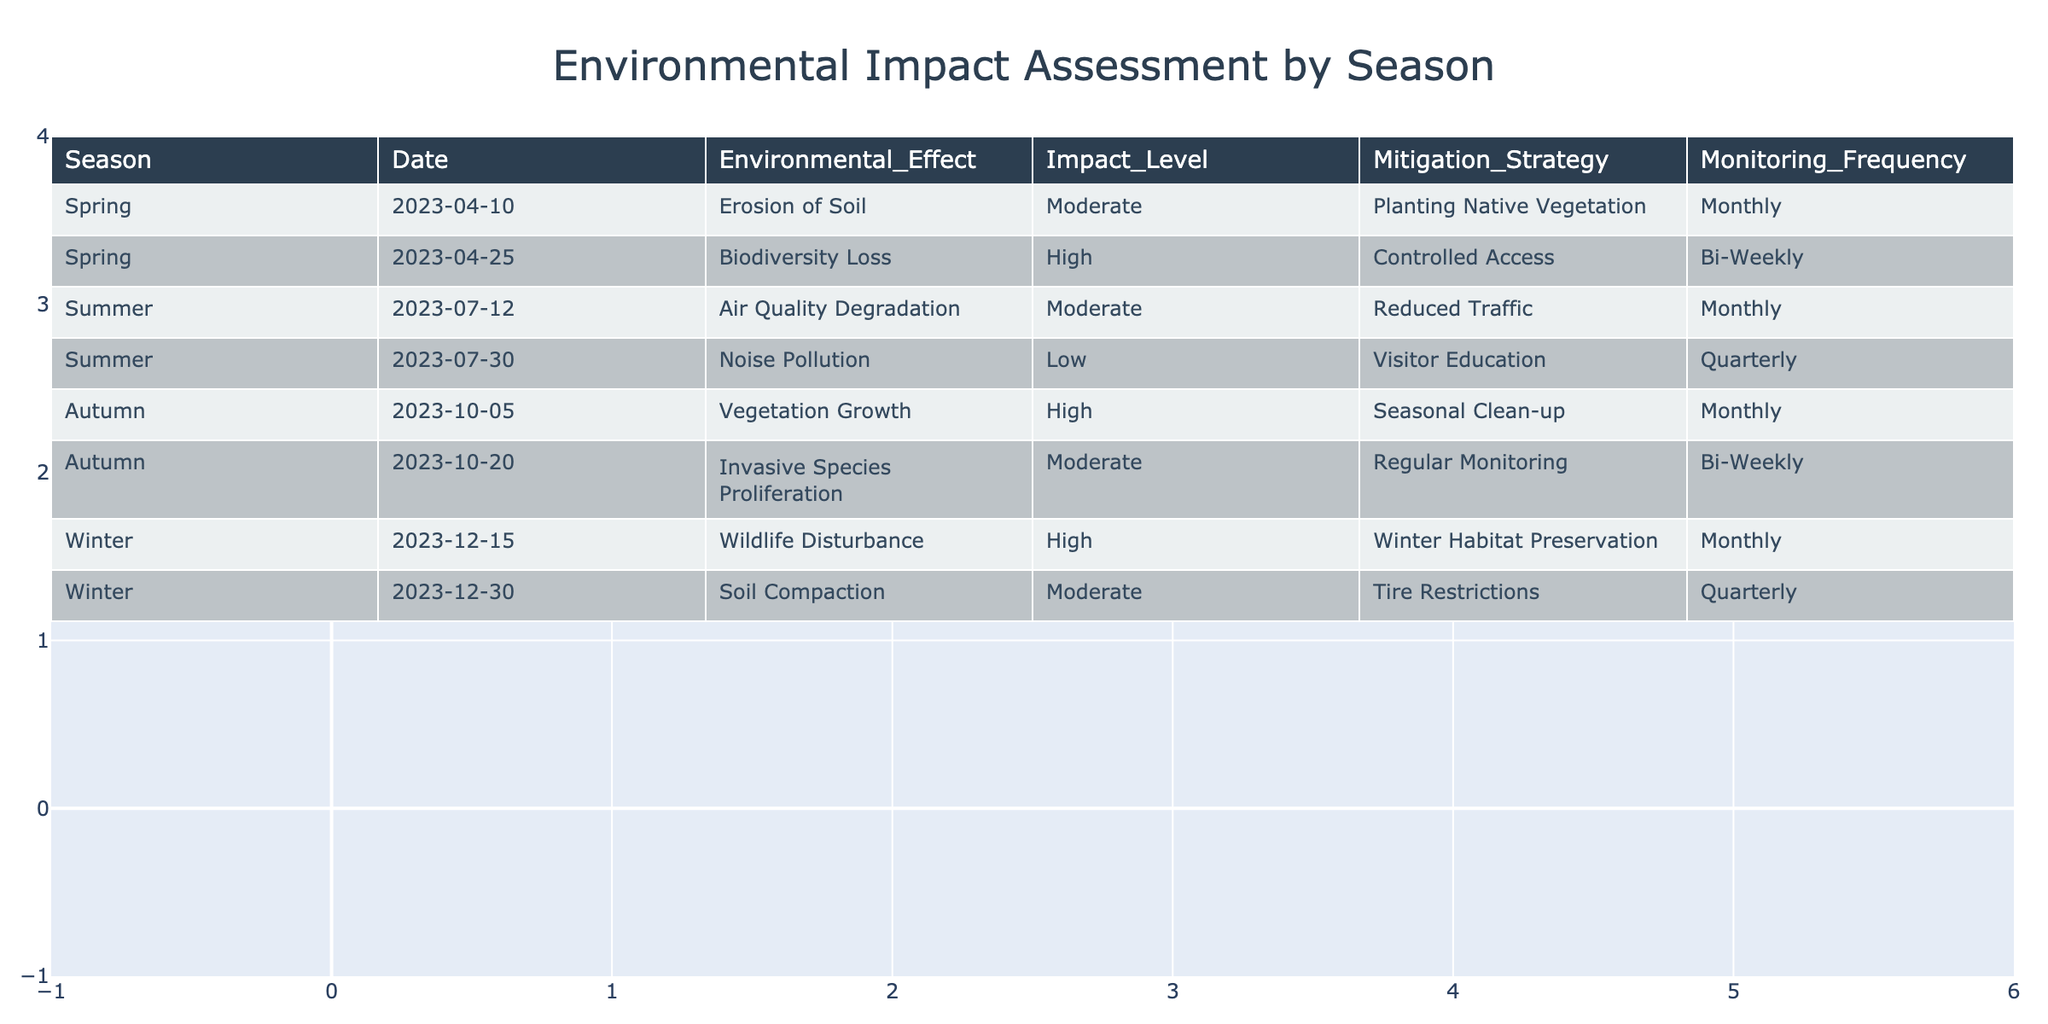What is the environmental effect reported in summer? In the summer season, the table shows two environmental effects: Air Quality Degradation and Noise Pollution. The first one listed is Air Quality Degradation.
Answer: Air Quality Degradation Which season had the highest impact level reported? The table indicates the impact levels for each environmental effect. The highest impact level reported is 'High', which appears in Spring (for Biodiversity Loss), Autumn (for Vegetation Growth), and Winter (for Wildlife Disturbance).
Answer: Spring, Autumn, Winter How many different mitigation strategies are employed across all seasons? A review of the table shows six distinct mitigation strategies: Planting Native Vegetation, Controlled Access, Reduced Traffic, Visitor Education, Seasonal Clean-up, and Winter Habitat Preservation. Counting these gives a total of six strategies.
Answer: 6 What is the monitoring frequency for noise pollution? The table specifies that the monitoring frequency for noise pollution is labeled as 'Quarterly'. This is directly stated in the Summer section of the table.
Answer: Quarterly Which season has the most environmental effects recorded? In the table, each season contains a different number of environmental effects. Spring has 2, Summer has 2, Autumn has 2, and Winter has 2 effects listed. Therefore, all seasons have the same number of recorded effects.
Answer: All seasons have the same amount Is soil compaction considered a high environmental impact? The table categorizes soil compaction under 'Moderate' impact level. This determination can be made by examining the impact level specified for soil compaction within the Winter season.
Answer: No How many seasonal cleanup activities are scheduled? The data mentions a seasonal clean-up strategy listed under Autumn for Vegetation Growth. Since there is only one occurrence of this strategy across all the seasons, the total is one seasonal cleanup activity.
Answer: 1 What is the average impact level across the four seasons? By tallying the impact levels (Moderate, High, Moderate, Low, High, Moderate, High, Moderate) and converting them into numerical form (Moderate=2, High=3, Low=1), and summing these totals gives a value to average. There are 8 entries yielding an average impact level of (2+3+2+1+3+2+3+2)/8 = 2.25.
Answer: 2.25 What is the mitigation strategy for biodiversity loss? The mitigation strategy for biodiversity loss, as indicated in the Spring section, is Controlled Access. This detail can be found in the environmental effect row associated with Spring.
Answer: Controlled Access Does the site experience vegetation growth in winter? The data reveals that vegetation growth is categorized under Autumn, not Winter. Therefore, it does not experience vegetation growth in the Winter season as per the table contents.
Answer: No 